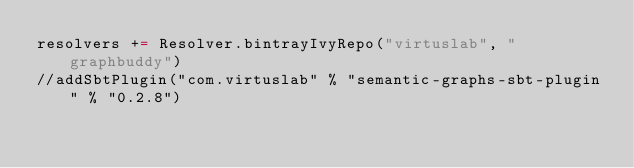Convert code to text. <code><loc_0><loc_0><loc_500><loc_500><_Scala_>resolvers += Resolver.bintrayIvyRepo("virtuslab", "graphbuddy")
//addSbtPlugin("com.virtuslab" % "semantic-graphs-sbt-plugin" % "0.2.8")</code> 